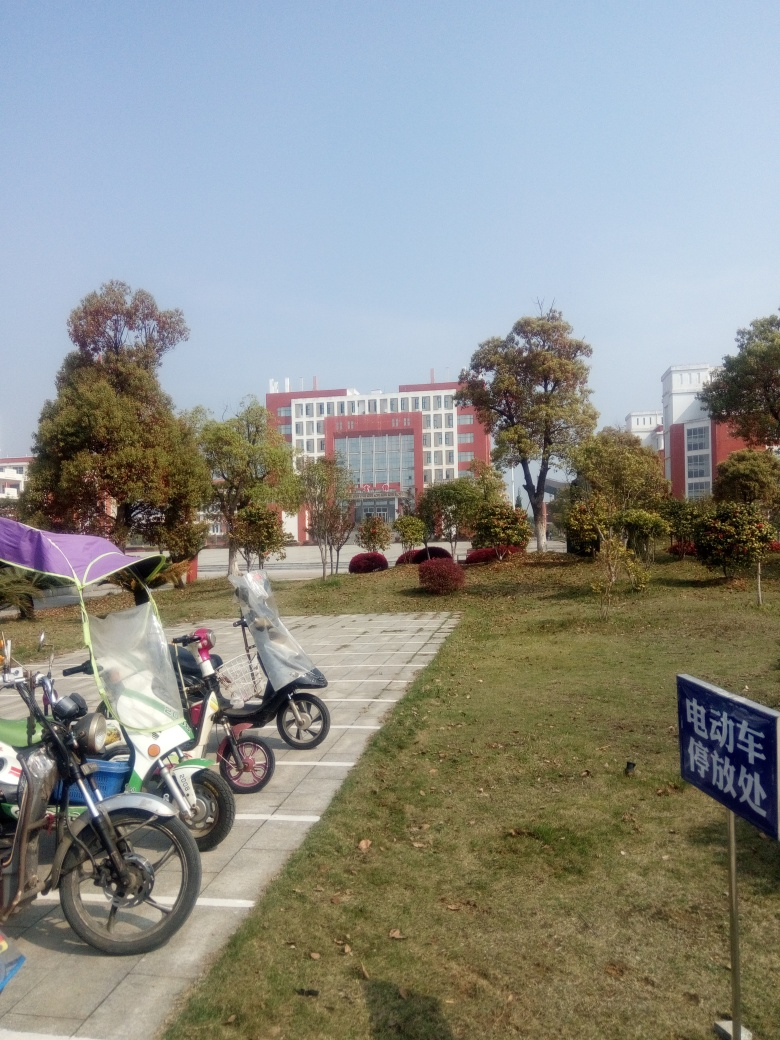Are there any signs or markings in the image that provide information about the location? Yes, there is a sign in the image with Chinese characters, indicating that the photo is likely taken in a Chinese-speaking region. However, without a clear view or context of what the sign says, it's hard to determine the exact location or the nature of the area. Can you speculate on the type of building in the background based on its design? The design of the building, with its large windows and symmetrical shape, suggests that it could be an educational or government institution. The structure appears modern and functional, which is often characteristic of public buildings. 